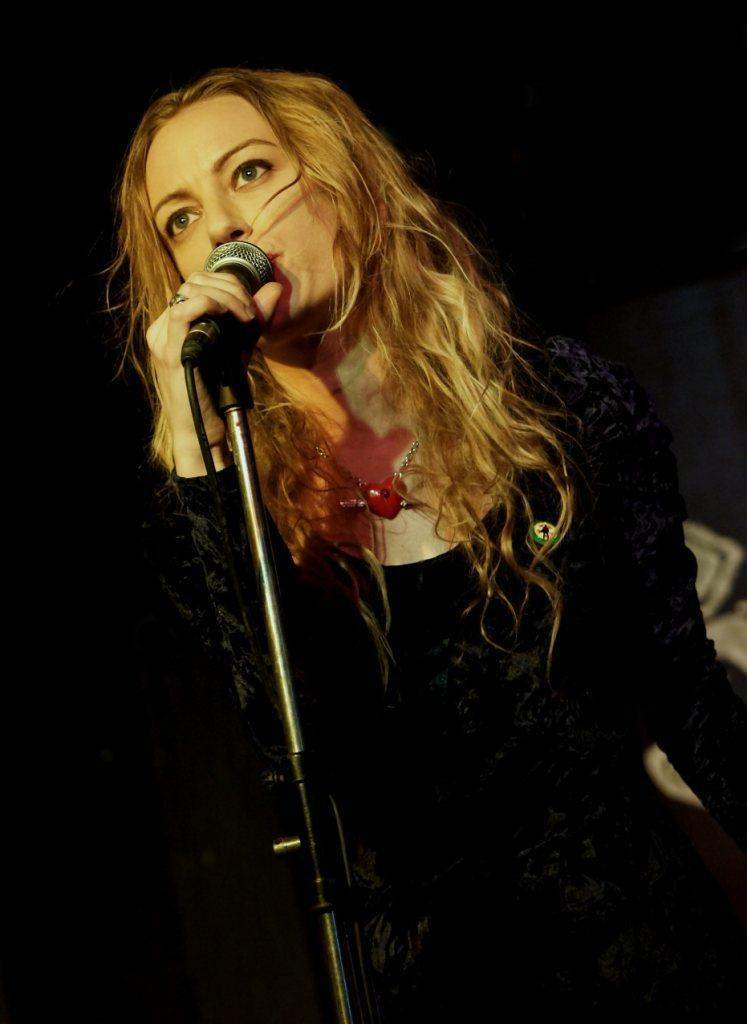Who is the main subject in the image? There is a woman in the image. What is the woman doing in the image? The woman is standing in front of a microphone. Can you describe the background of the image? The background appears to be dark. What time of day might the image have been taken? The image may have been taken during the night, given the dark background. Where might the scene be taking place? The scene appears to be on a stage. Can you see any nests in the image? There are no nests visible in the image. What level of respect does the woman have for the audience in the image? The image does not provide any information about the woman's level of respect for the audience. 